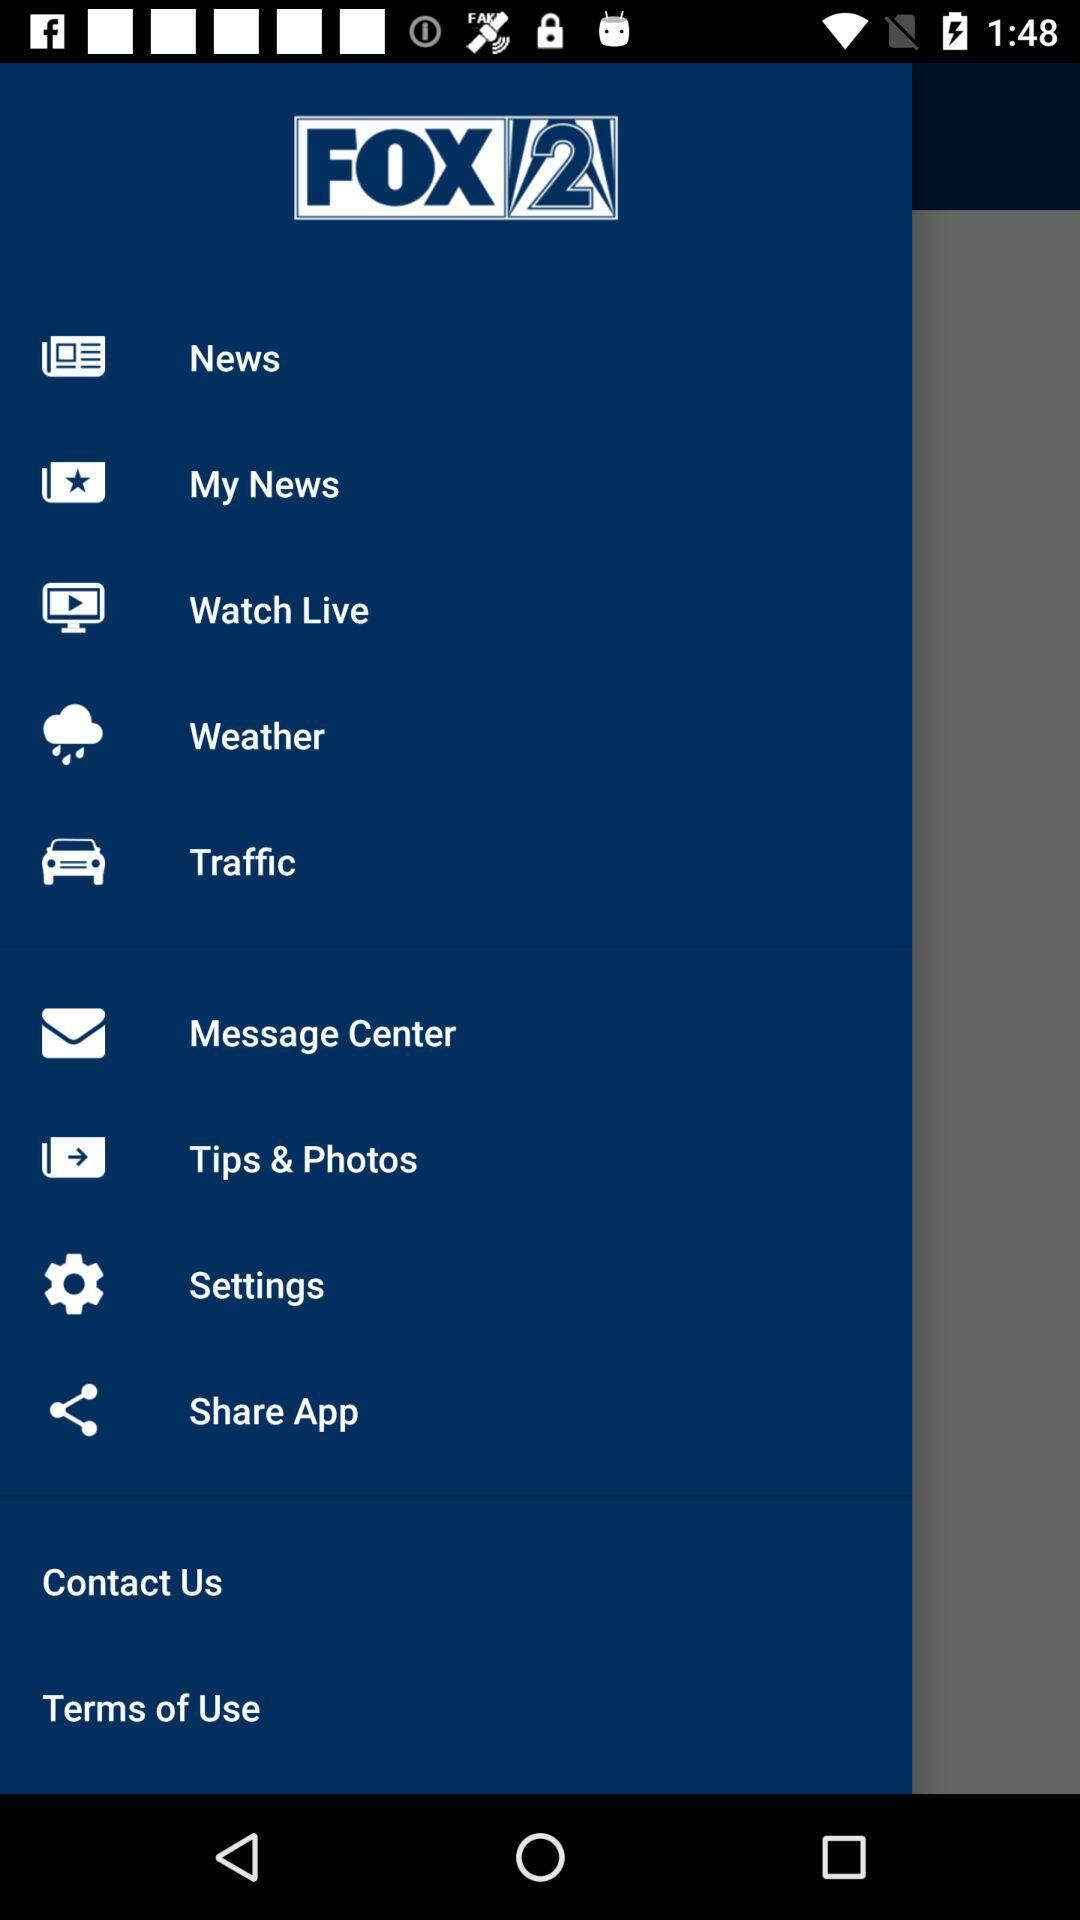What is the name of the application? The name of the application is "FOX 2". 